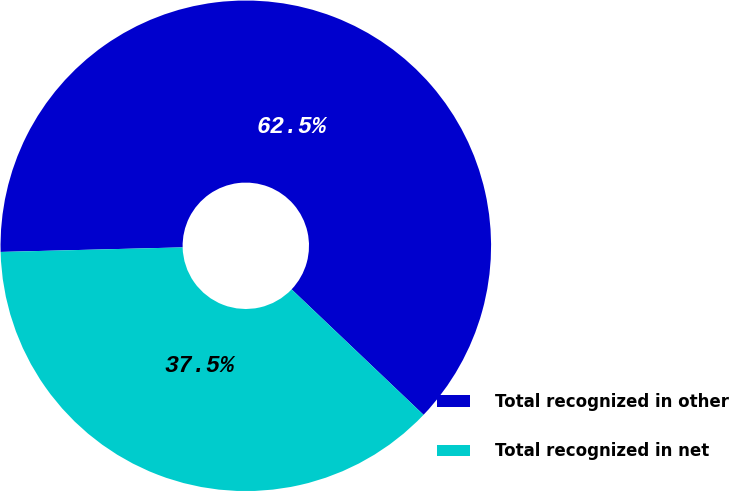Convert chart. <chart><loc_0><loc_0><loc_500><loc_500><pie_chart><fcel>Total recognized in other<fcel>Total recognized in net<nl><fcel>62.5%<fcel>37.5%<nl></chart> 